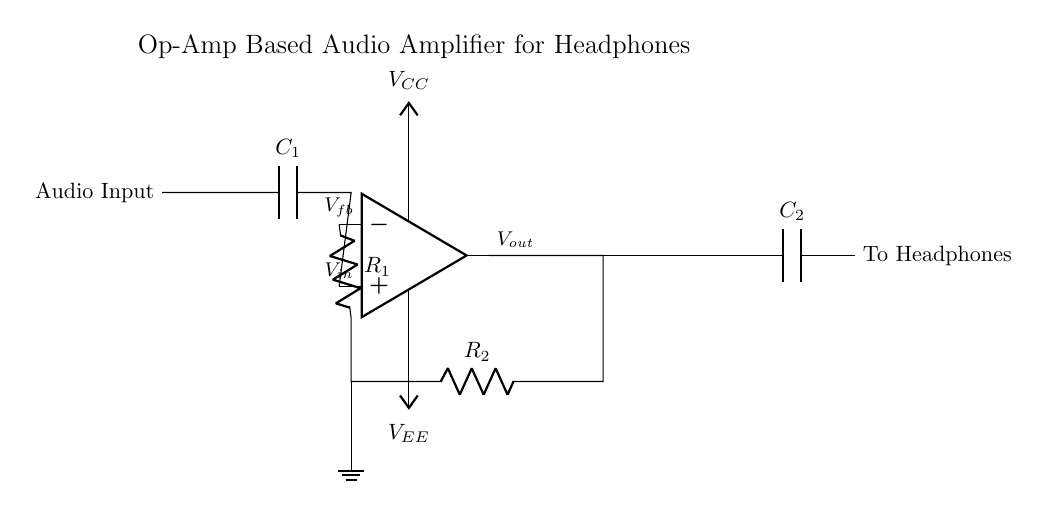What is the main component used in this circuit? The main component of this circuit is the operational amplifier (op-amp), which is the central element that amplifies the audio input signal.
Answer: op-amp What do the capacitors C1 and C2 do? Capacitor C1 is used for AC coupling of the audio input signal, blocking any DC component, while capacitor C2 couples the amplified AC output to the headphones.
Answer: AC coupling What is the purpose of resistors R1 and R2? Resistors R1 and R2 form a feedback network for controlling the gain of the op-amp, thereby affecting the output signal's amplitude based on the input signal.
Answer: Gain control What are the supply voltages indicated in the circuit? The supply voltages for the op-amp are labeled as VCC (positive supply voltage) and VEE (negative supply voltage), which provide the necessary power for the op-amp to operate.
Answer: VCC and VEE What would happen if C1 were removed from the circuit? If C1 is removed, the DC offset of the audio input signal may pass through to the op-amp input, potentially damaging the op-amp or affecting the performance negatively.
Answer: Potential damage How can you describe the output of the circuit? The output of this audio amplifier circuit is the amplified audio signal, which is suitable for driving headphones and is labeled as Vout in the diagram.
Answer: Amplified audio signal 